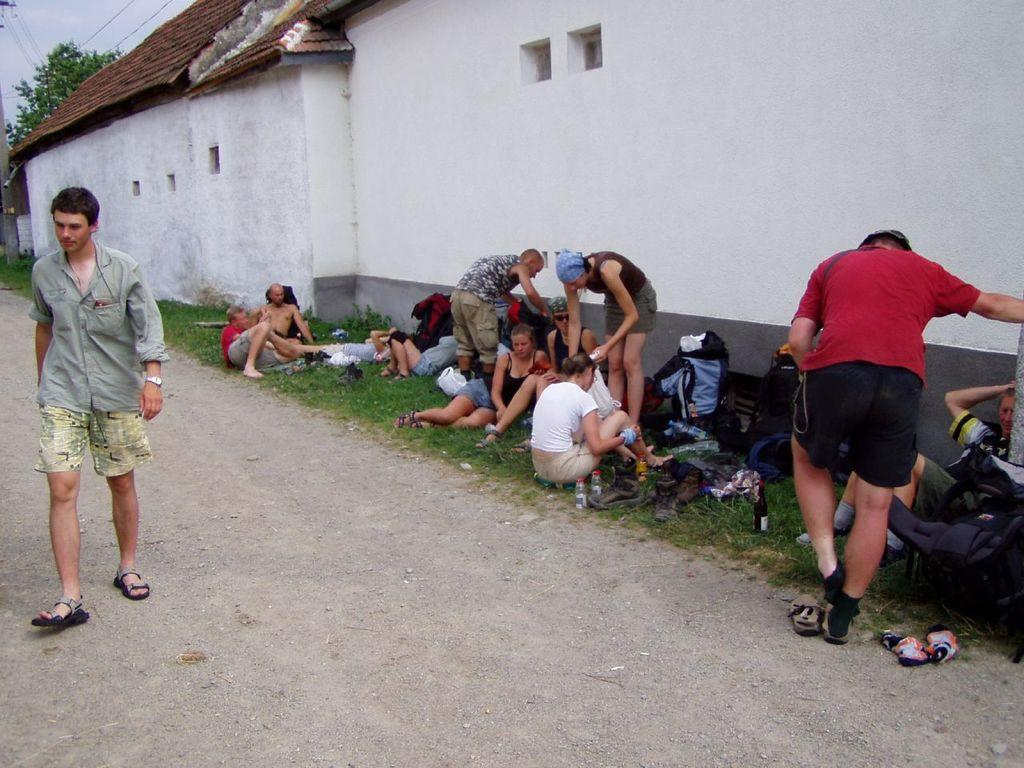What is the man doing on the left side of the image? The man is walking on the left side of the image. What are the people on the right side of the image doing? Some people are sitting, while others are standing on the right side of the image. What can be seen in the background of the image? There are sheds, a tree, wires, and the sky visible in the background of the image. What type of bun is being used to power the machine in the image? There is no machine or bun present in the image. How does the man turn the corner in the image? The image does not show the man turning a corner; he is simply walking on the left side of the image. 